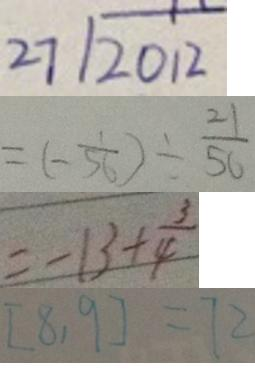<formula> <loc_0><loc_0><loc_500><loc_500>2 7 \sqrt { 2 0 1 2 } 
 = ( - \frac { 1 } { 5 6 } ) \div \frac { 2 1 } { 5 6 } 
 = - 1 3 + \frac { 3 } { 4 } 
 [ 8 , 9 ] = 7 2</formula> 